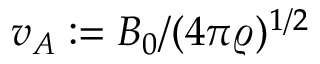<formula> <loc_0><loc_0><loc_500><loc_500>v _ { A } \colon = B _ { 0 } / ( 4 \pi \varrho ) ^ { 1 / 2 }</formula> 